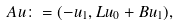Convert formula to latex. <formula><loc_0><loc_0><loc_500><loc_500>A u \colon = ( - u _ { 1 } , L u _ { 0 } + B u _ { 1 } ) ,</formula> 